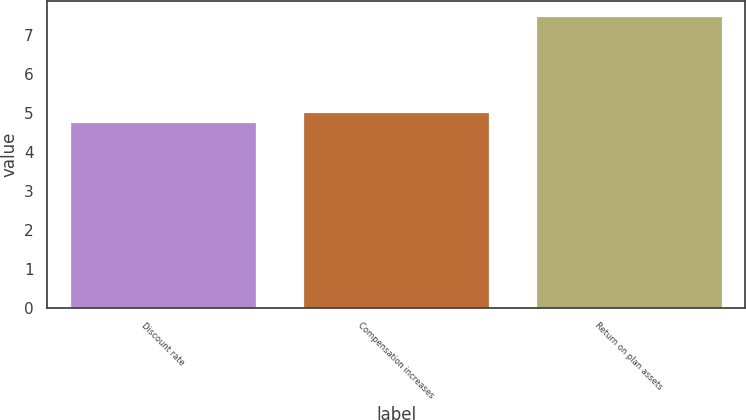Convert chart. <chart><loc_0><loc_0><loc_500><loc_500><bar_chart><fcel>Discount rate<fcel>Compensation increases<fcel>Return on plan assets<nl><fcel>4.76<fcel>5.03<fcel>7.5<nl></chart> 